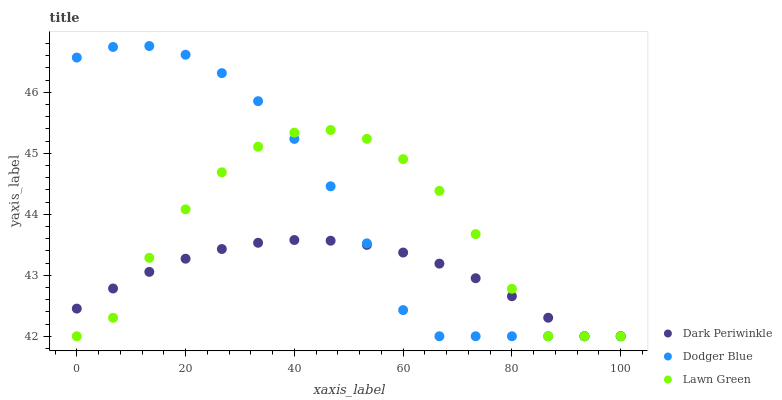Does Dark Periwinkle have the minimum area under the curve?
Answer yes or no. Yes. Does Dodger Blue have the maximum area under the curve?
Answer yes or no. Yes. Does Dodger Blue have the minimum area under the curve?
Answer yes or no. No. Does Dark Periwinkle have the maximum area under the curve?
Answer yes or no. No. Is Dark Periwinkle the smoothest?
Answer yes or no. Yes. Is Lawn Green the roughest?
Answer yes or no. Yes. Is Dodger Blue the smoothest?
Answer yes or no. No. Is Dodger Blue the roughest?
Answer yes or no. No. Does Lawn Green have the lowest value?
Answer yes or no. Yes. Does Dodger Blue have the highest value?
Answer yes or no. Yes. Does Dark Periwinkle have the highest value?
Answer yes or no. No. Does Dodger Blue intersect Dark Periwinkle?
Answer yes or no. Yes. Is Dodger Blue less than Dark Periwinkle?
Answer yes or no. No. Is Dodger Blue greater than Dark Periwinkle?
Answer yes or no. No. 